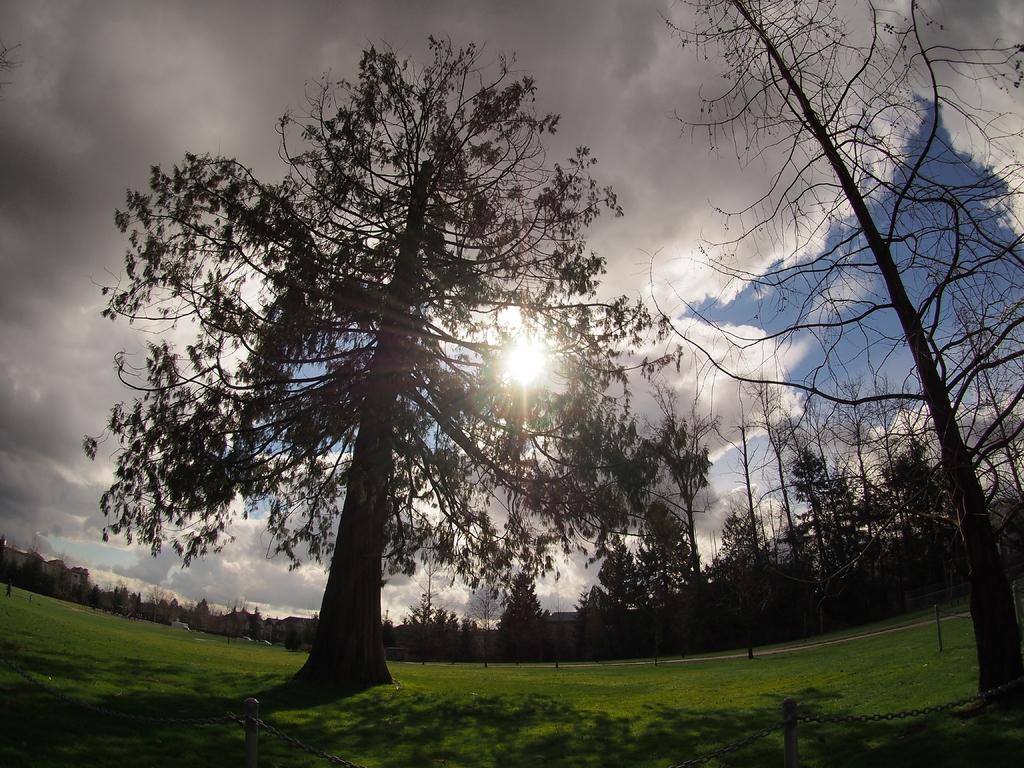What type of vegetation can be seen in the image? There are trees in the image. What type of structures are present in the image? There are buildings in the image. What is visible at the top of the image? The sky is visible at the top of the image. What can be seen in the sky? There are clouds and the sun visible in the sky. What type of ground surface is at the bottom of the image? There is grass at the bottom of the image. What is located in the foreground of the image? There is a railing in the foreground of the image. Can you tell me how many corn plants are growing in the image? There is no corn plant present in the image; it features trees and grass. What type of vehicle is being driven in the image? There is no vehicle or driving activity depicted in the image. 